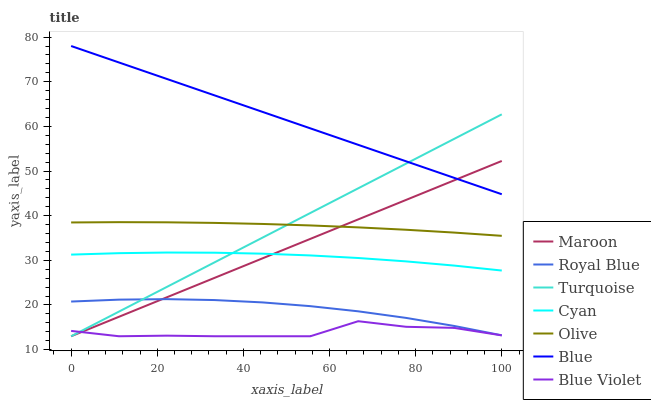Does Blue Violet have the minimum area under the curve?
Answer yes or no. Yes. Does Blue have the maximum area under the curve?
Answer yes or no. Yes. Does Turquoise have the minimum area under the curve?
Answer yes or no. No. Does Turquoise have the maximum area under the curve?
Answer yes or no. No. Is Maroon the smoothest?
Answer yes or no. Yes. Is Blue Violet the roughest?
Answer yes or no. Yes. Is Turquoise the smoothest?
Answer yes or no. No. Is Turquoise the roughest?
Answer yes or no. No. Does Turquoise have the lowest value?
Answer yes or no. Yes. Does Royal Blue have the lowest value?
Answer yes or no. No. Does Blue have the highest value?
Answer yes or no. Yes. Does Turquoise have the highest value?
Answer yes or no. No. Is Olive less than Blue?
Answer yes or no. Yes. Is Blue greater than Cyan?
Answer yes or no. Yes. Does Maroon intersect Blue Violet?
Answer yes or no. Yes. Is Maroon less than Blue Violet?
Answer yes or no. No. Is Maroon greater than Blue Violet?
Answer yes or no. No. Does Olive intersect Blue?
Answer yes or no. No. 